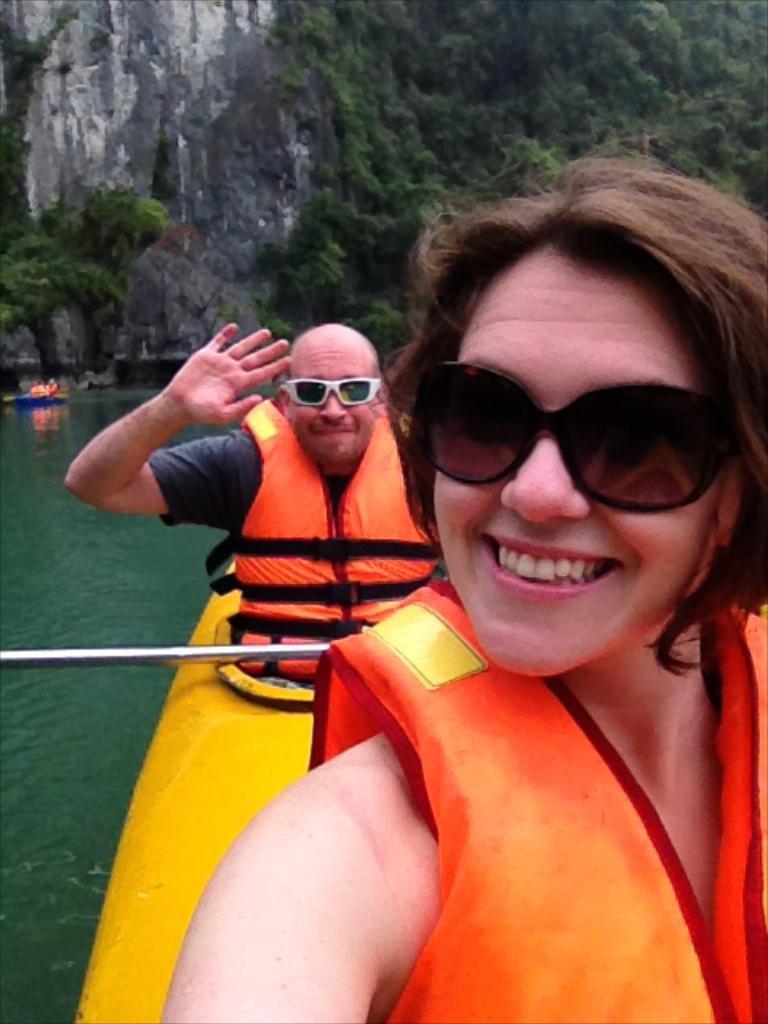Describe this image in one or two sentences. In this image we can see there are boats on the water and there are people sitting on the boat and holding an iron rod. At the back there are trees and rock. 